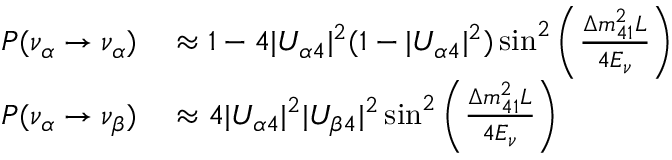<formula> <loc_0><loc_0><loc_500><loc_500>\begin{array} { r l } { P ( \nu _ { \alpha } \to \nu _ { \alpha } ) } & \approx 1 - 4 | U _ { \alpha 4 } | ^ { 2 } ( 1 - | U _ { \alpha 4 } | ^ { 2 } ) \sin ^ { 2 } \left ( \frac { \Delta m _ { 4 1 } ^ { 2 } L } { 4 E _ { \nu } } \right ) } \\ { P ( \nu _ { \alpha } \to \nu _ { \beta } ) } & \approx 4 | U _ { \alpha 4 } | ^ { 2 } | U _ { \beta 4 } | ^ { 2 } \sin ^ { 2 } \left ( \frac { \Delta m _ { 4 1 } ^ { 2 } L } { 4 E _ { \nu } } \right ) } \end{array}</formula> 